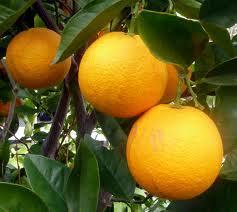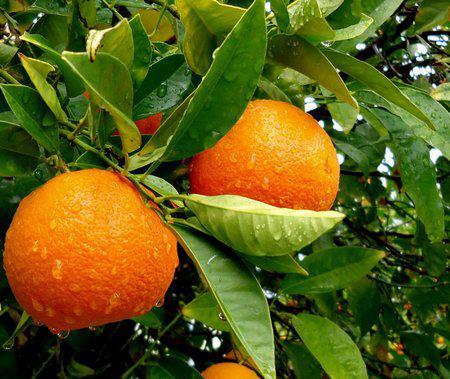The first image is the image on the left, the second image is the image on the right. Analyze the images presented: Is the assertion "An orange tree is flowering." valid? Answer yes or no. No. 